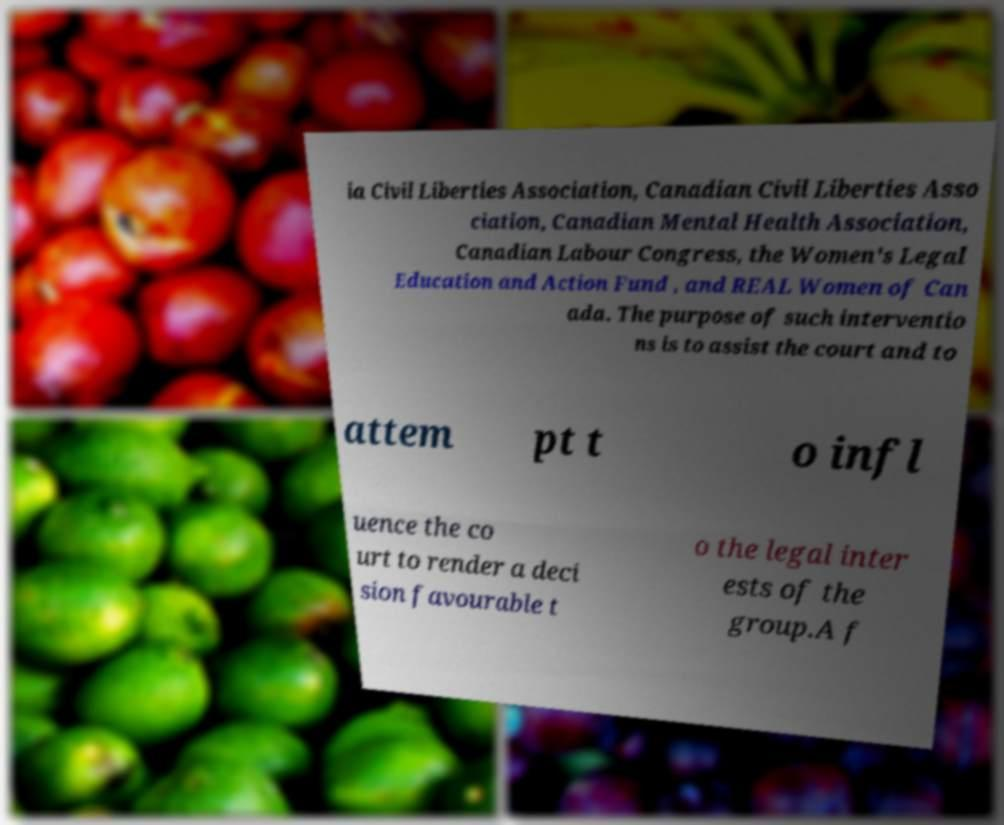Can you accurately transcribe the text from the provided image for me? ia Civil Liberties Association, Canadian Civil Liberties Asso ciation, Canadian Mental Health Association, Canadian Labour Congress, the Women's Legal Education and Action Fund , and REAL Women of Can ada. The purpose of such interventio ns is to assist the court and to attem pt t o infl uence the co urt to render a deci sion favourable t o the legal inter ests of the group.A f 